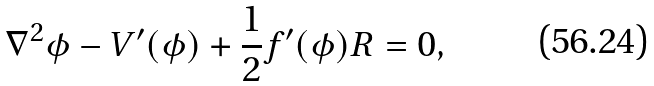Convert formula to latex. <formula><loc_0><loc_0><loc_500><loc_500>\nabla ^ { 2 } \phi - V ^ { \prime } ( \phi ) + \frac { 1 } { 2 } f ^ { \prime } ( \phi ) R = 0 ,</formula> 